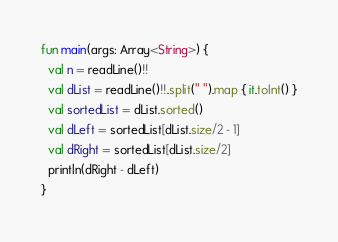Convert code to text. <code><loc_0><loc_0><loc_500><loc_500><_Kotlin_>fun main(args: Array<String>) {
  val n = readLine()!!
  val dList = readLine()!!.split(" ").map { it.toInt() }
  val sortedList = dList.sorted()
  val dLeft = sortedList[dList.size/2 - 1]
  val dRight = sortedList[dList.size/2]
  println(dRight - dLeft)
}</code> 